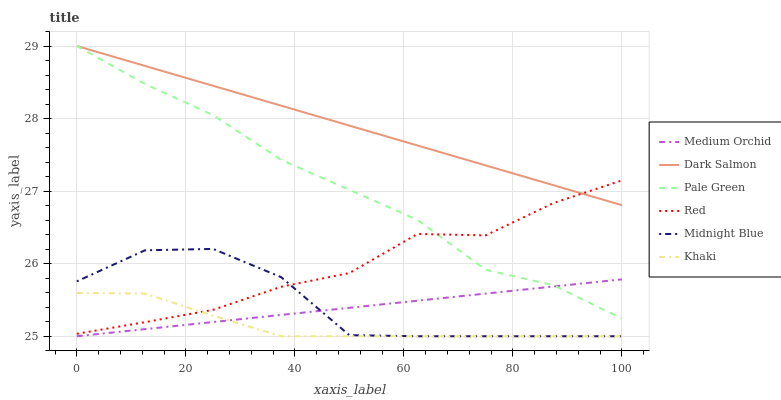Does Khaki have the minimum area under the curve?
Answer yes or no. Yes. Does Dark Salmon have the maximum area under the curve?
Answer yes or no. Yes. Does Midnight Blue have the minimum area under the curve?
Answer yes or no. No. Does Midnight Blue have the maximum area under the curve?
Answer yes or no. No. Is Dark Salmon the smoothest?
Answer yes or no. Yes. Is Midnight Blue the roughest?
Answer yes or no. Yes. Is Medium Orchid the smoothest?
Answer yes or no. No. Is Medium Orchid the roughest?
Answer yes or no. No. Does Khaki have the lowest value?
Answer yes or no. Yes. Does Dark Salmon have the lowest value?
Answer yes or no. No. Does Pale Green have the highest value?
Answer yes or no. Yes. Does Midnight Blue have the highest value?
Answer yes or no. No. Is Khaki less than Pale Green?
Answer yes or no. Yes. Is Pale Green greater than Midnight Blue?
Answer yes or no. Yes. Does Khaki intersect Midnight Blue?
Answer yes or no. Yes. Is Khaki less than Midnight Blue?
Answer yes or no. No. Is Khaki greater than Midnight Blue?
Answer yes or no. No. Does Khaki intersect Pale Green?
Answer yes or no. No. 